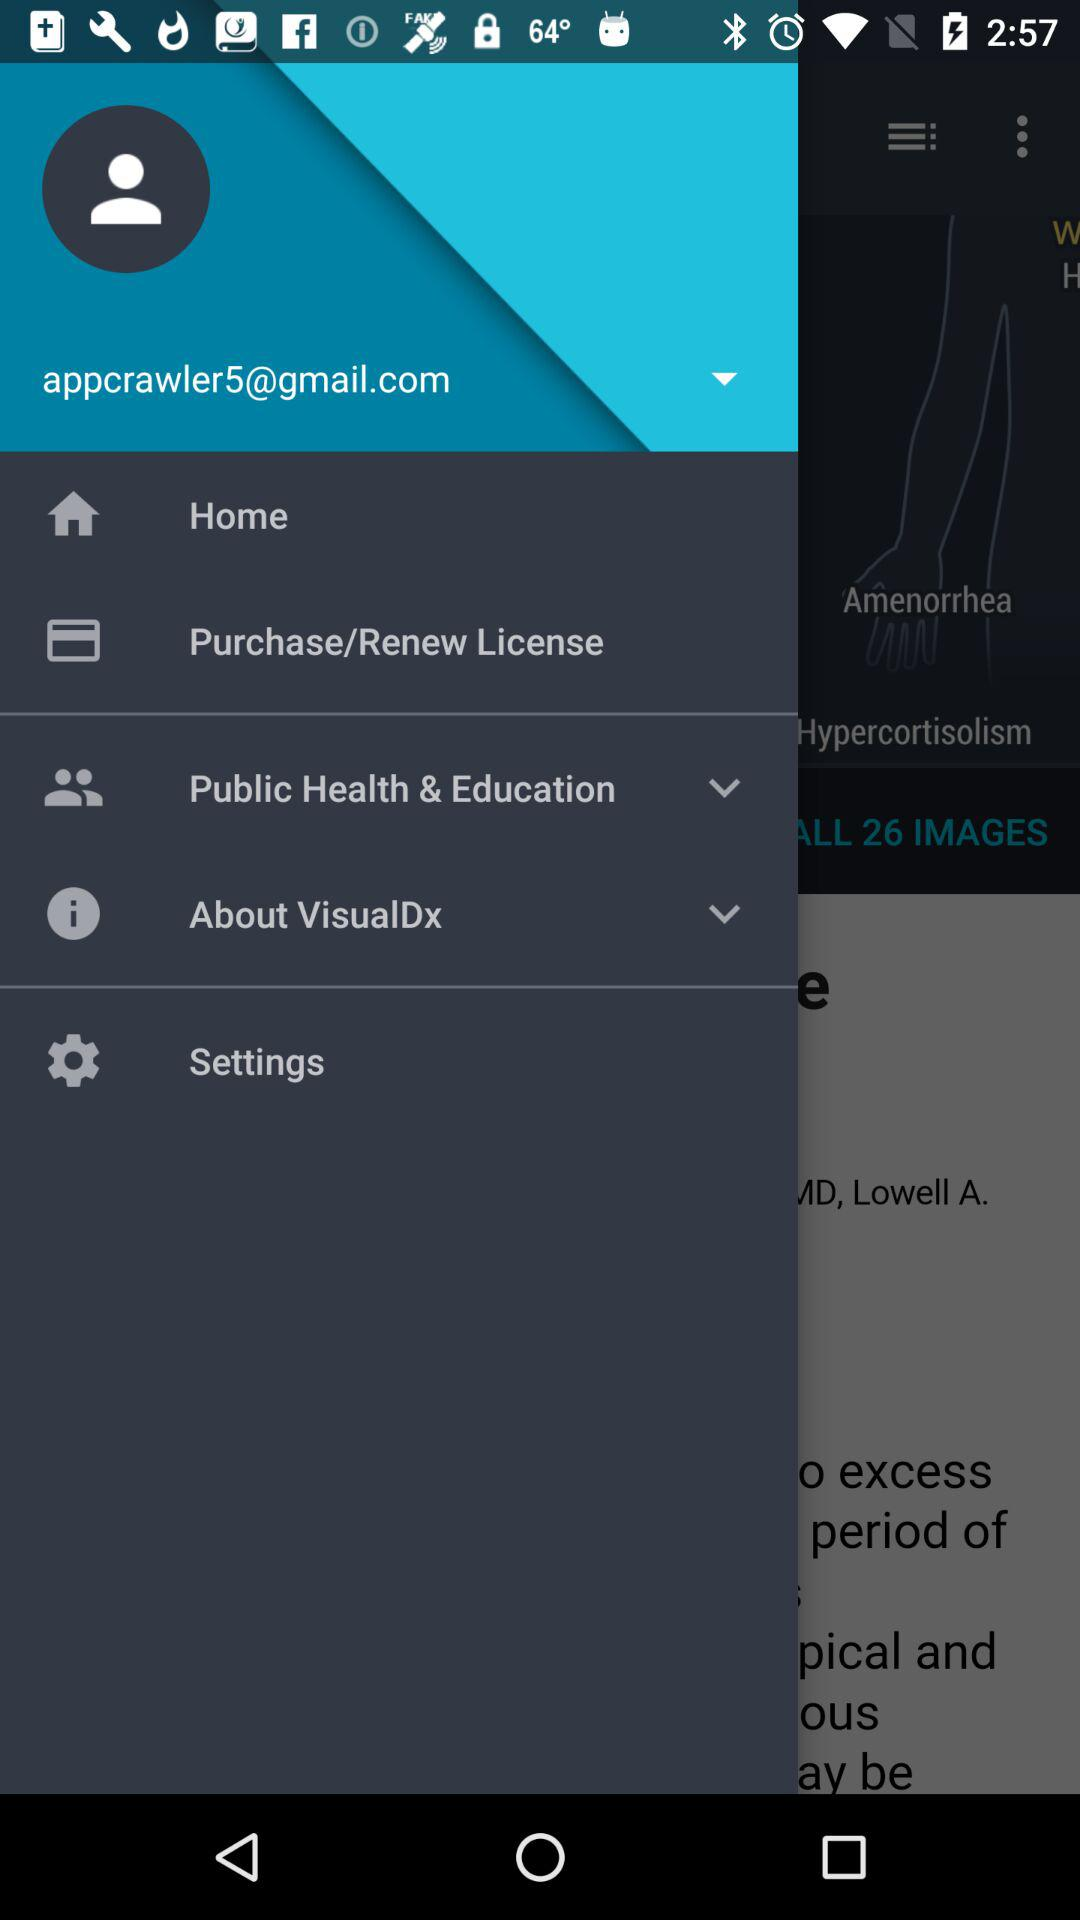What's the email address used by the user for the application? The email address used is "appcrawler5@gmail.com". 